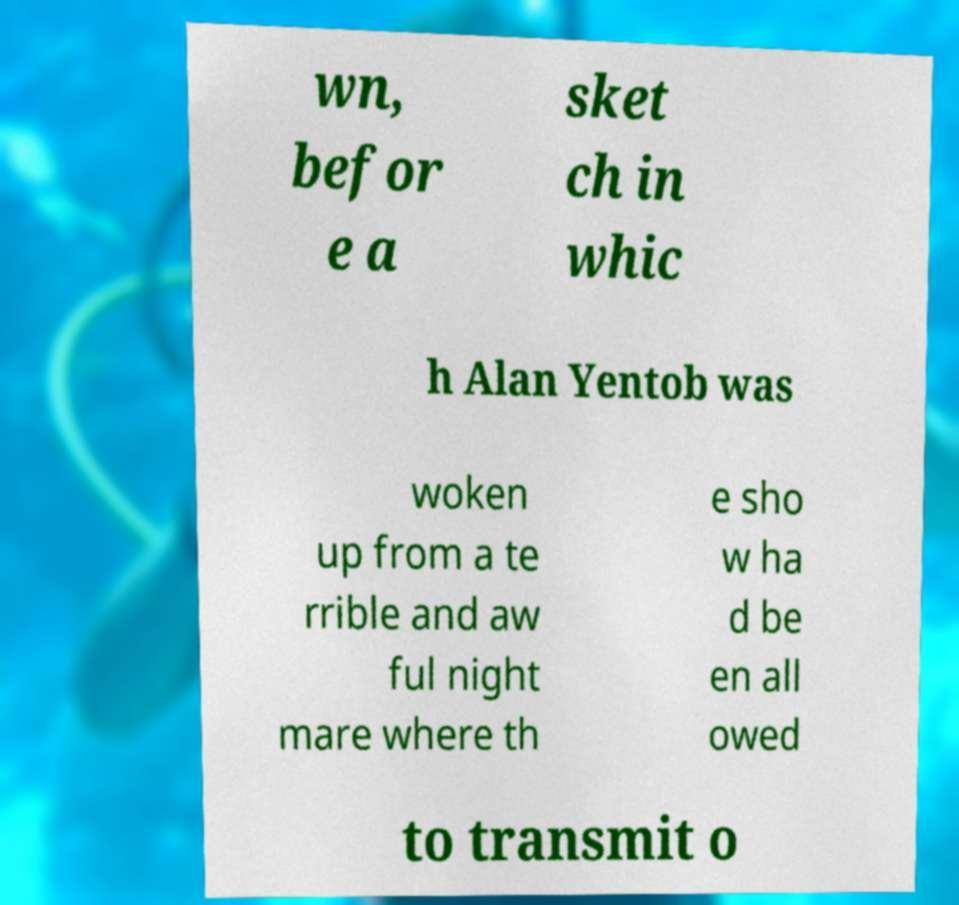What messages or text are displayed in this image? I need them in a readable, typed format. wn, befor e a sket ch in whic h Alan Yentob was woken up from a te rrible and aw ful night mare where th e sho w ha d be en all owed to transmit o 